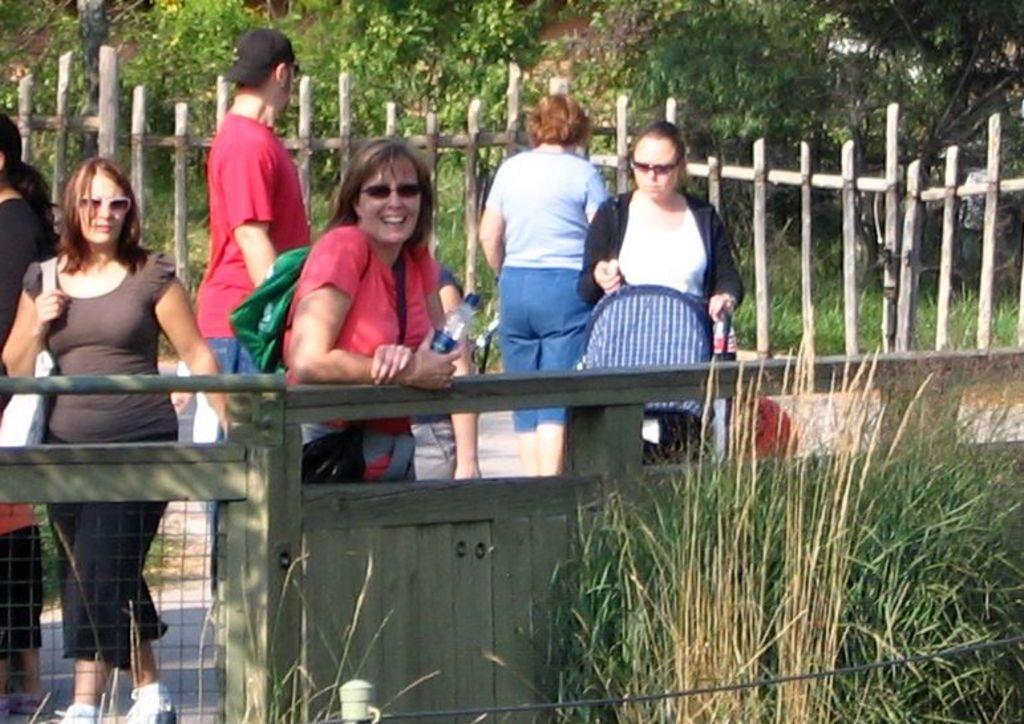Could you give a brief overview of what you see in this image? In this picture I can see a group of people in the middle, on the right side there is the grass, at the bottom it looks like a wooden wall, in the background there is a wooden fence and I can see few trees. 